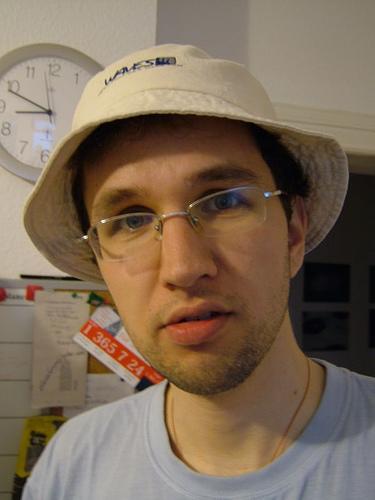What number is the big hand on the clock nearest?
Quick response, please. 10. Is the man's mode of dress casual or formal?
Be succinct. Casual. What's the phone number that's behind this man?
Be succinct. 1 365 7 24. 